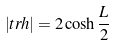<formula> <loc_0><loc_0><loc_500><loc_500>| t r h | = 2 \cosh \frac { L } { 2 }</formula> 